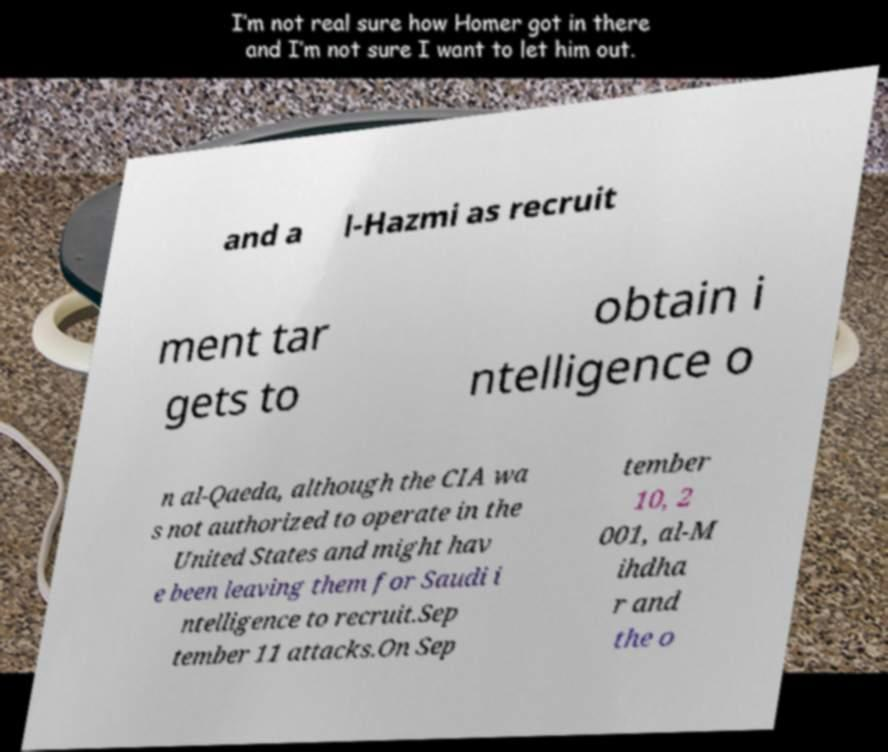Can you accurately transcribe the text from the provided image for me? and a l-Hazmi as recruit ment tar gets to obtain i ntelligence o n al-Qaeda, although the CIA wa s not authorized to operate in the United States and might hav e been leaving them for Saudi i ntelligence to recruit.Sep tember 11 attacks.On Sep tember 10, 2 001, al-M ihdha r and the o 